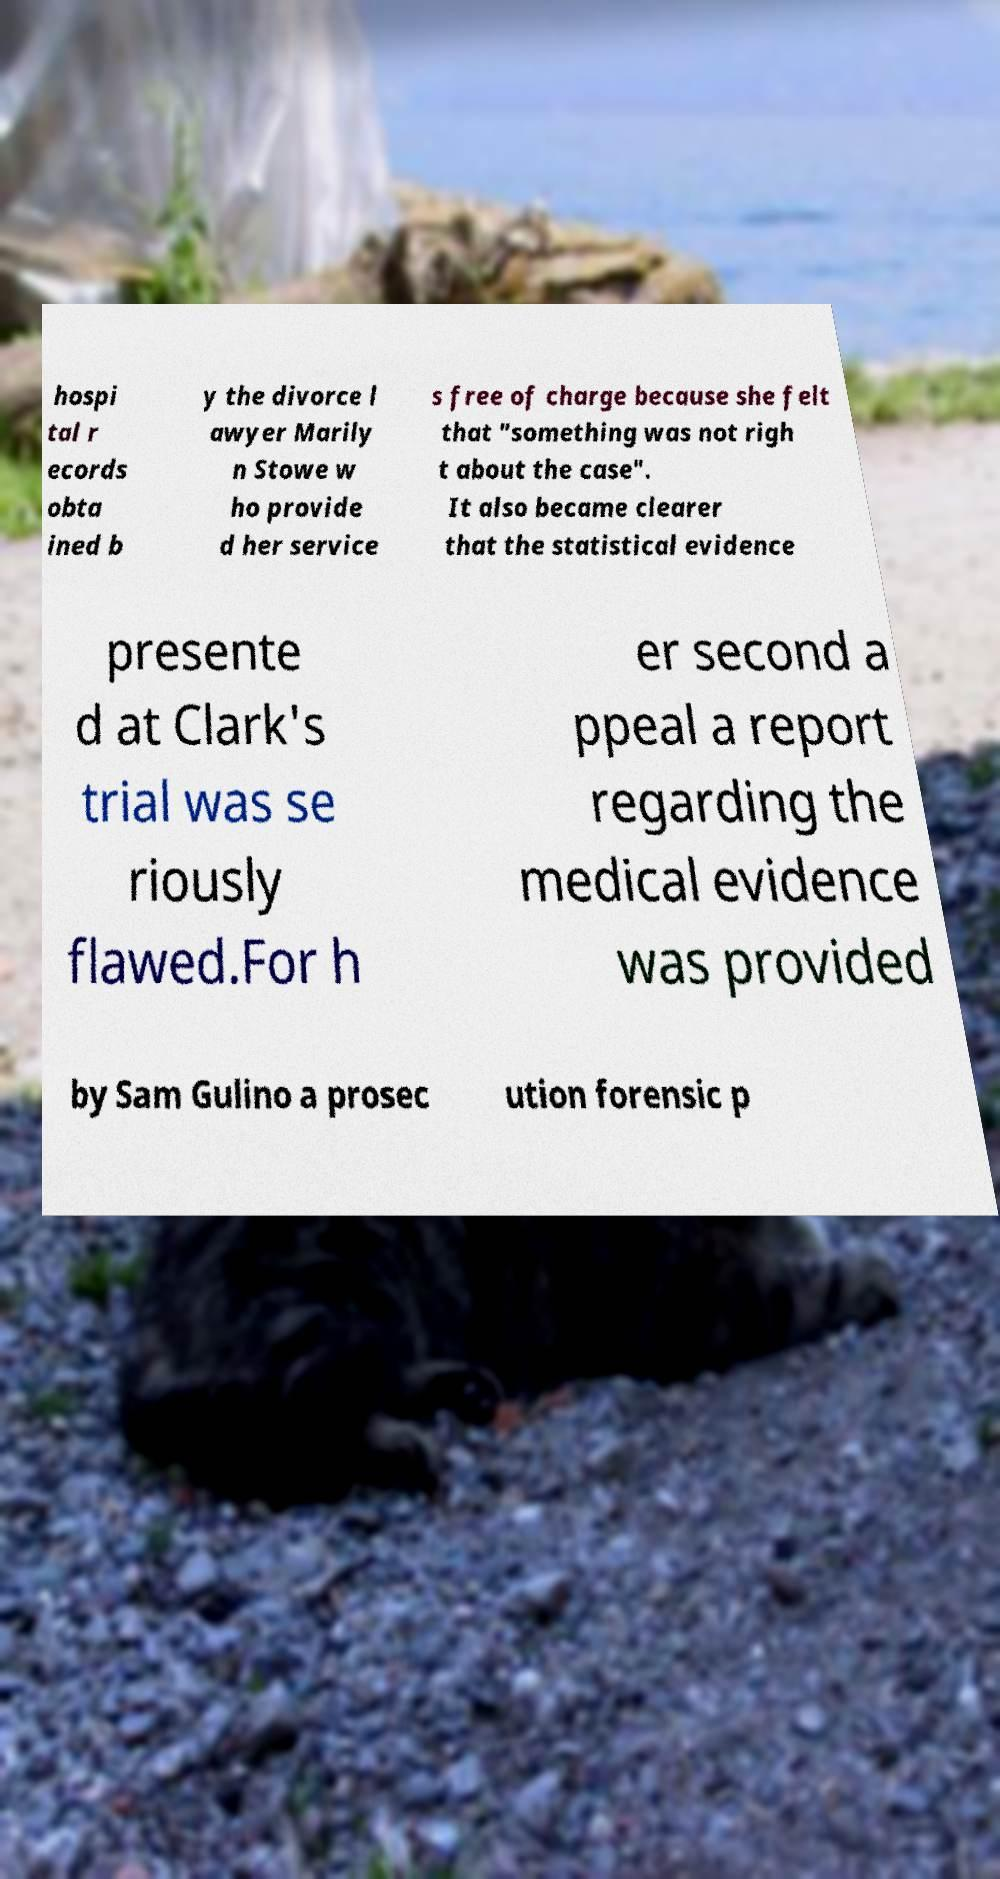Can you accurately transcribe the text from the provided image for me? hospi tal r ecords obta ined b y the divorce l awyer Marily n Stowe w ho provide d her service s free of charge because she felt that "something was not righ t about the case". It also became clearer that the statistical evidence presente d at Clark's trial was se riously flawed.For h er second a ppeal a report regarding the medical evidence was provided by Sam Gulino a prosec ution forensic p 